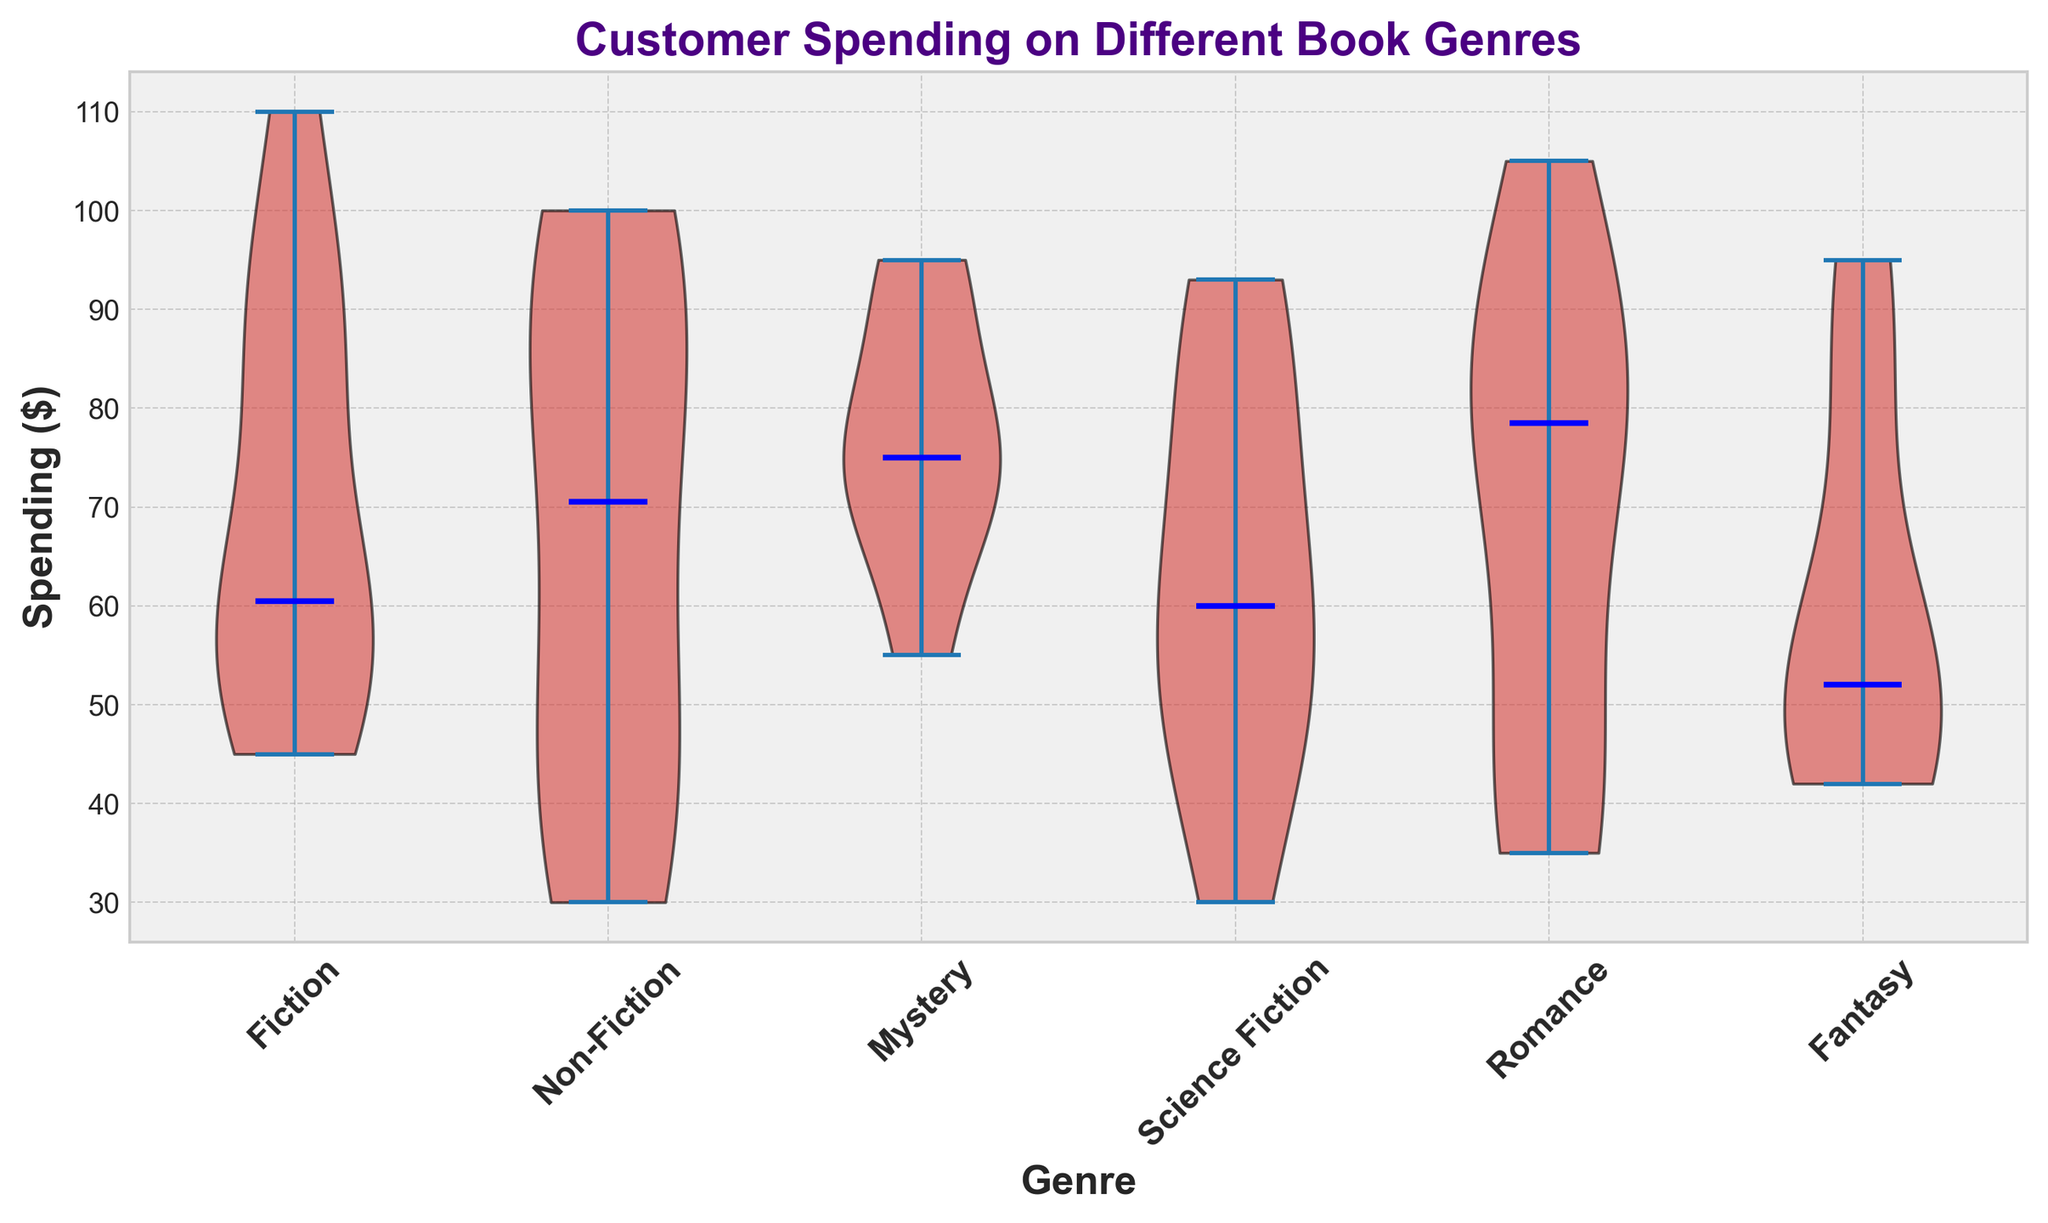What is the median spending on Fiction books? To find the median spending on Fiction books, we observe the violin plot for the Fiction category and look for the horizontal blue line which indicates the median value.
Answer: 58 Which genre shows the highest median spending? We compare the heights of the blue horizontal lines (medians) across all genres in the violin plot. The genre with the highest median line represents the highest median spending.
Answer: Non-Fiction Are Mystery books usually more expensive than Romance books based on spending? By comparing the median lines of Mystery and Romance categories, we see that the median spending for Mystery books is lower than for Romance books, indicating Romance books are usually more expensive.
Answer: No What is the range of spending for Science Fiction books? The range is the difference between the maximum and minimum values for the Science Fiction category, as indicated by the extent of the red violins.
Answer: 63 (95-32) Which genre has the greatest variability in spending? The greatest variability is shown by the widest spread or length of the red violins. We look for the genre with the most extended violin plot from top to bottom.
Answer: Fiction How does the median spending on Fantasy books compare to Non-Fiction? We compare the median lines (blue) of Fantasy and Non-Fiction categories, finding that Non-Fiction has a higher median line than Fantasy.
Answer: Non-Fiction > Fantasy What is the difference in median spending between Science Fiction and Mystery books? We identify the median spending values for Science Fiction and Mystery from their respective blue lines and compute the difference.
Answer: 5 (80-75) Which genre shows a spending median closer to 70 dollars? We look at the blue median lines on the plot and find which one is closest to the value of 70 dollars.
Answer: Mystery Is the median spending on Mystery books closer to Fiction or Romance books? By comparing the median lines, we see if the median of Mystery books lies closer to the median line of Fiction or Romance.
Answer: Romance 